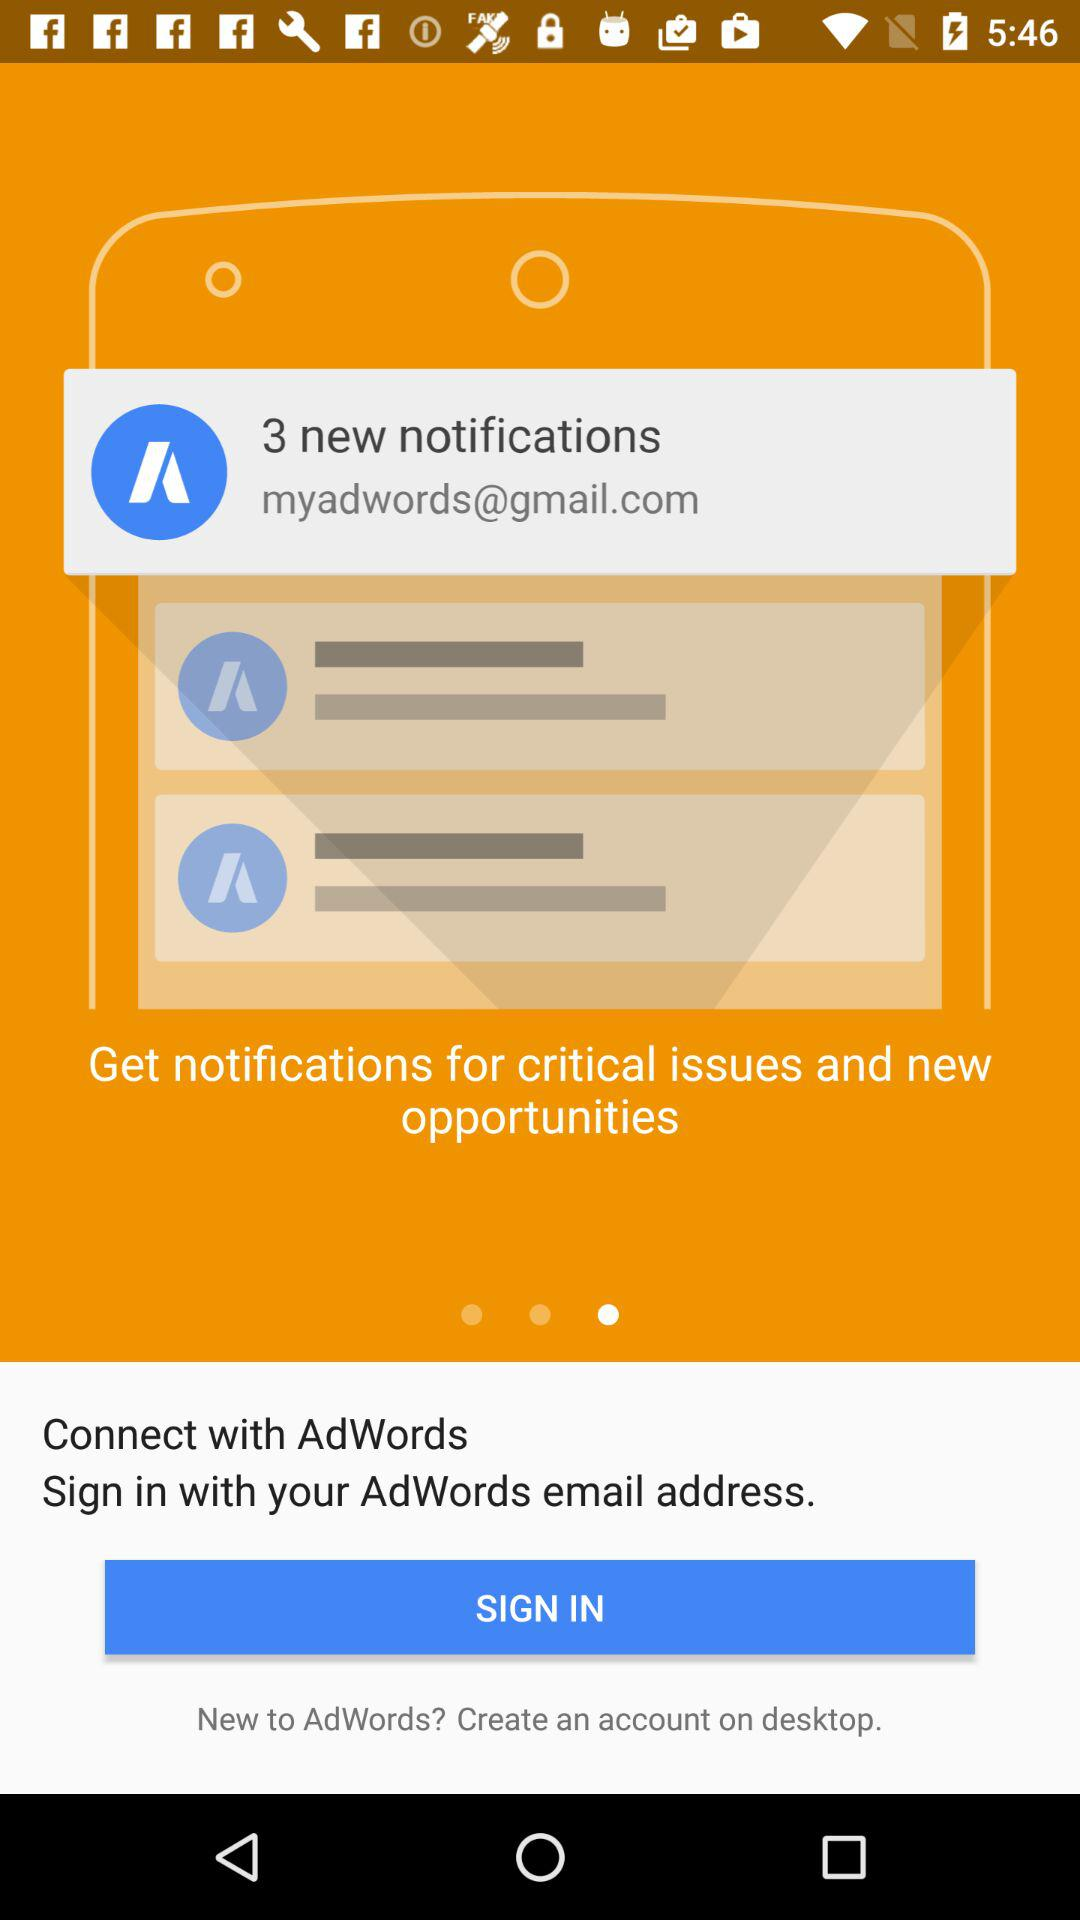How many notifications are pending? There are 3 notifications pending. 